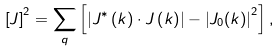<formula> <loc_0><loc_0><loc_500><loc_500>\left [ J \right ] ^ { 2 } = \sum _ { q } \left [ \left | J ^ { \ast } \left ( k \right ) \cdot J \left ( k \right ) \right | - \left | J _ { 0 } ( k ) \right | ^ { 2 } \right ] ,</formula> 